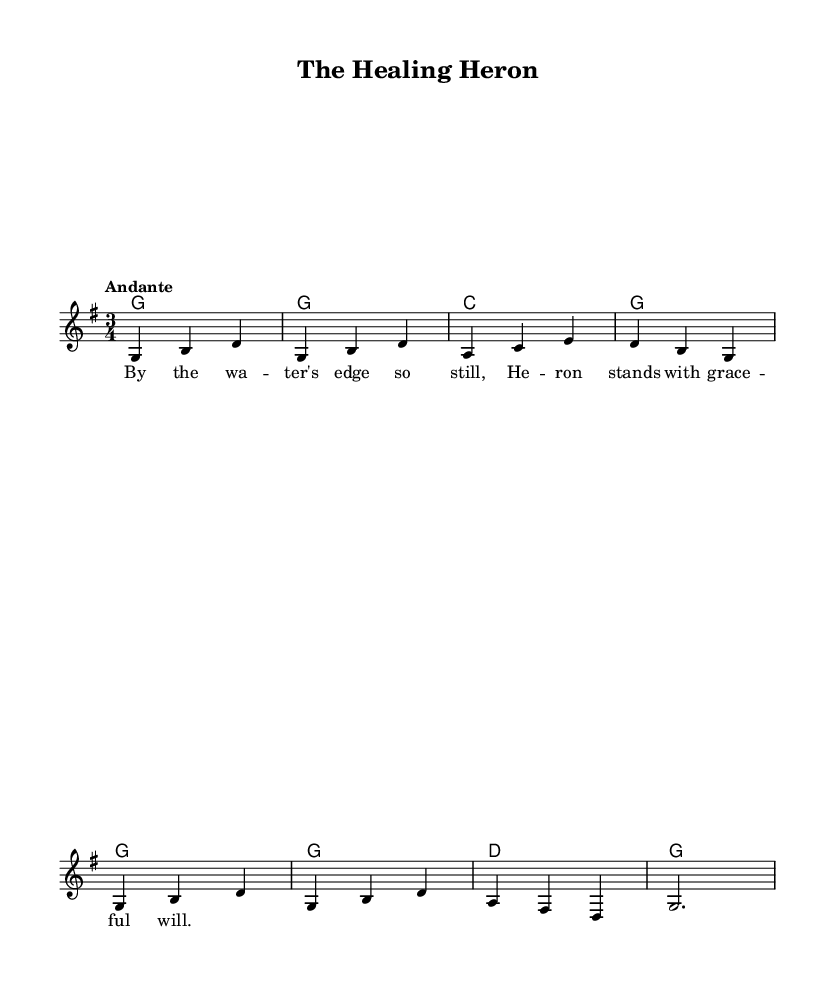What is the key signature of this music? The key signature is G major, which has one sharp (F#). This can be identified by looking at the beginning of the staff where the sharps are indicated.
Answer: G major What is the time signature of this music? The time signature is 3/4. This is seen in the notation at the beginning of the piece, indicating three beats per measure.
Answer: 3/4 What tempo marking is provided in the music? The tempo marking is "Andante," which indicates a moderate tempo. This term is written above the staff and informs the musician of the intended speed.
Answer: Andante How many measures are in the melody section? The melody section consists of eight measures. This is determined by counting the grouped patterns of notes and taking into account the defined measures throughout the melody.
Answer: Eight What animal is featured in the title of the song? The title of the song is "The Healing Heron," and the heron is mentioned as a symbol of grace and healing. This can be seen directly in the title at the top of the score.
Answer: Heron What is the primary theme expressed in the lyrics? The primary theme expressed in the lyrics is tranquility and grace associated with the heron by the water's edge. This is inferred from the imagery presented in the lyrics, which highlight the calmness and beauty of the heron.
Answer: Healing 